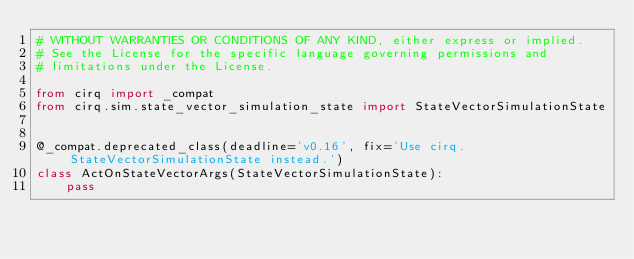Convert code to text. <code><loc_0><loc_0><loc_500><loc_500><_Python_># WITHOUT WARRANTIES OR CONDITIONS OF ANY KIND, either express or implied.
# See the License for the specific language governing permissions and
# limitations under the License.

from cirq import _compat
from cirq.sim.state_vector_simulation_state import StateVectorSimulationState


@_compat.deprecated_class(deadline='v0.16', fix='Use cirq.StateVectorSimulationState instead.')
class ActOnStateVectorArgs(StateVectorSimulationState):
    pass
</code> 